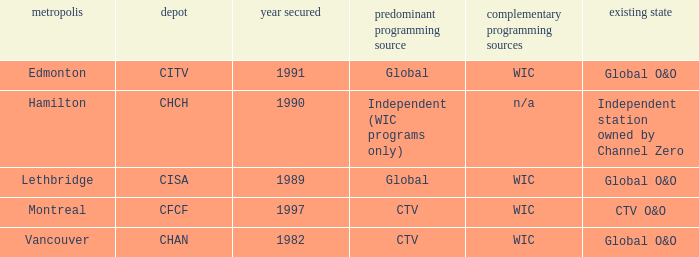How many channels were gained in 1997 1.0. 